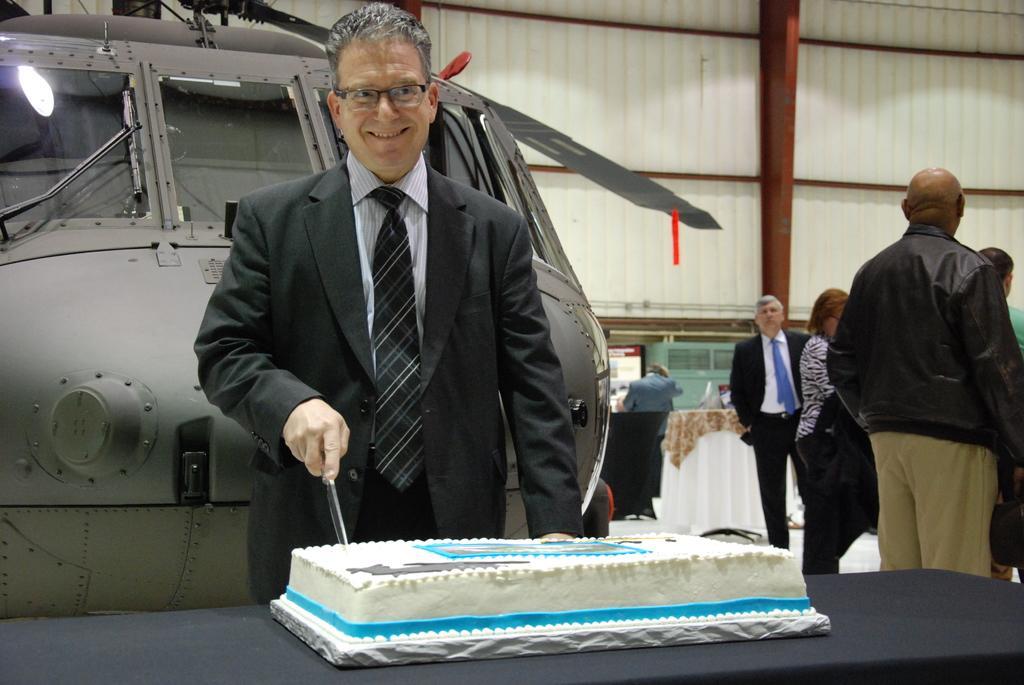Could you give a brief overview of what you see in this image? In the foreground I can see a person is cutting a cake with knife which is kept on the table. In the background I can see a crowd, an aircraft and a tent. This image is taken may be in a hall. 